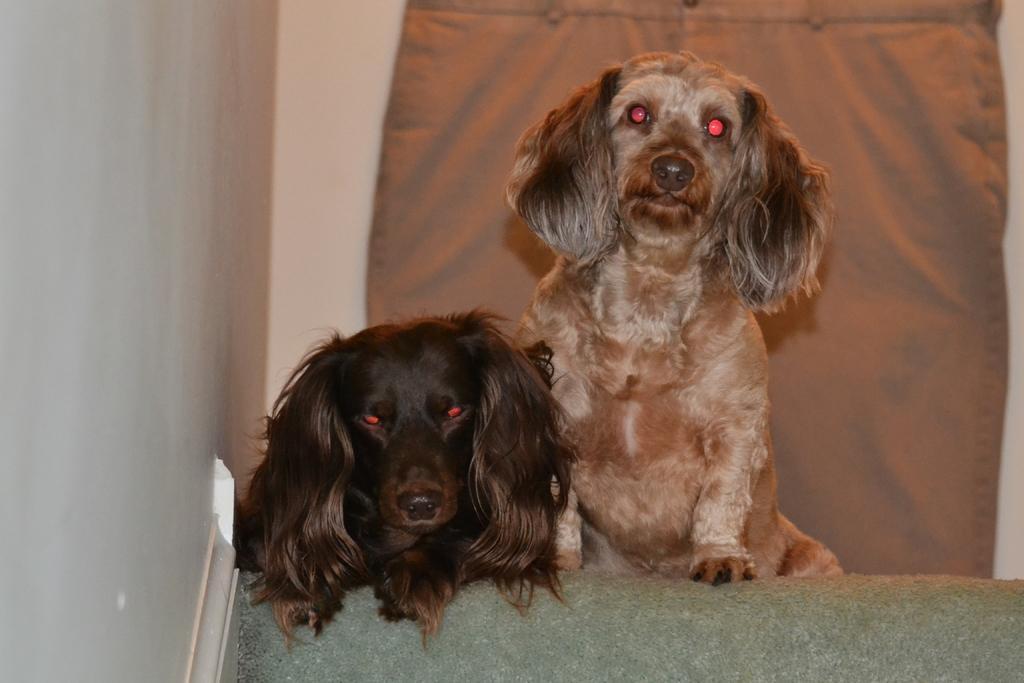Describe this image in one or two sentences. In this image in the center there are two dogs and on the left side and in the background there is a wall, and also in the background there is a cloth. At the bottom there is a couch 